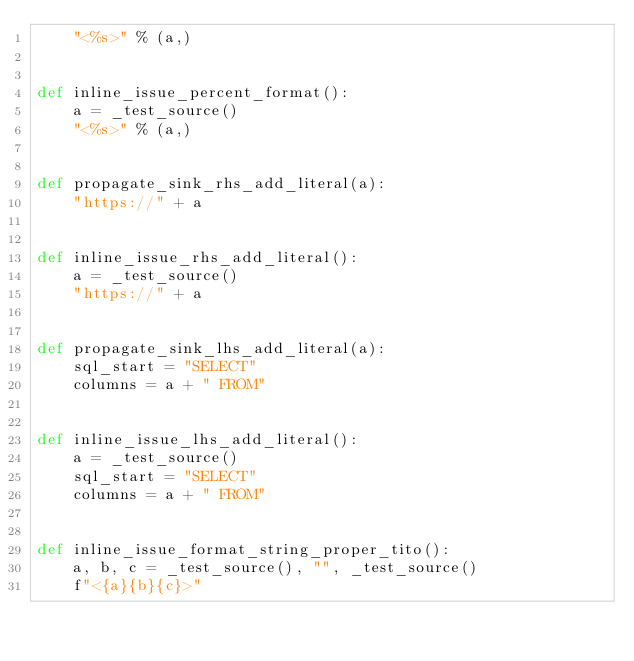Convert code to text. <code><loc_0><loc_0><loc_500><loc_500><_Python_>    "<%s>" % (a,)


def inline_issue_percent_format():
    a = _test_source()
    "<%s>" % (a,)


def propagate_sink_rhs_add_literal(a):
    "https://" + a


def inline_issue_rhs_add_literal():
    a = _test_source()
    "https://" + a


def propagate_sink_lhs_add_literal(a):
    sql_start = "SELECT"
    columns = a + " FROM"


def inline_issue_lhs_add_literal():
    a = _test_source()
    sql_start = "SELECT"
    columns = a + " FROM"


def inline_issue_format_string_proper_tito():
    a, b, c = _test_source(), "", _test_source()
    f"<{a}{b}{c}>"
</code> 